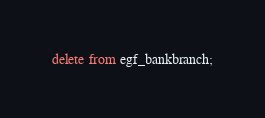Convert code to text. <code><loc_0><loc_0><loc_500><loc_500><_SQL_>delete from egf_bankbranch;</code> 